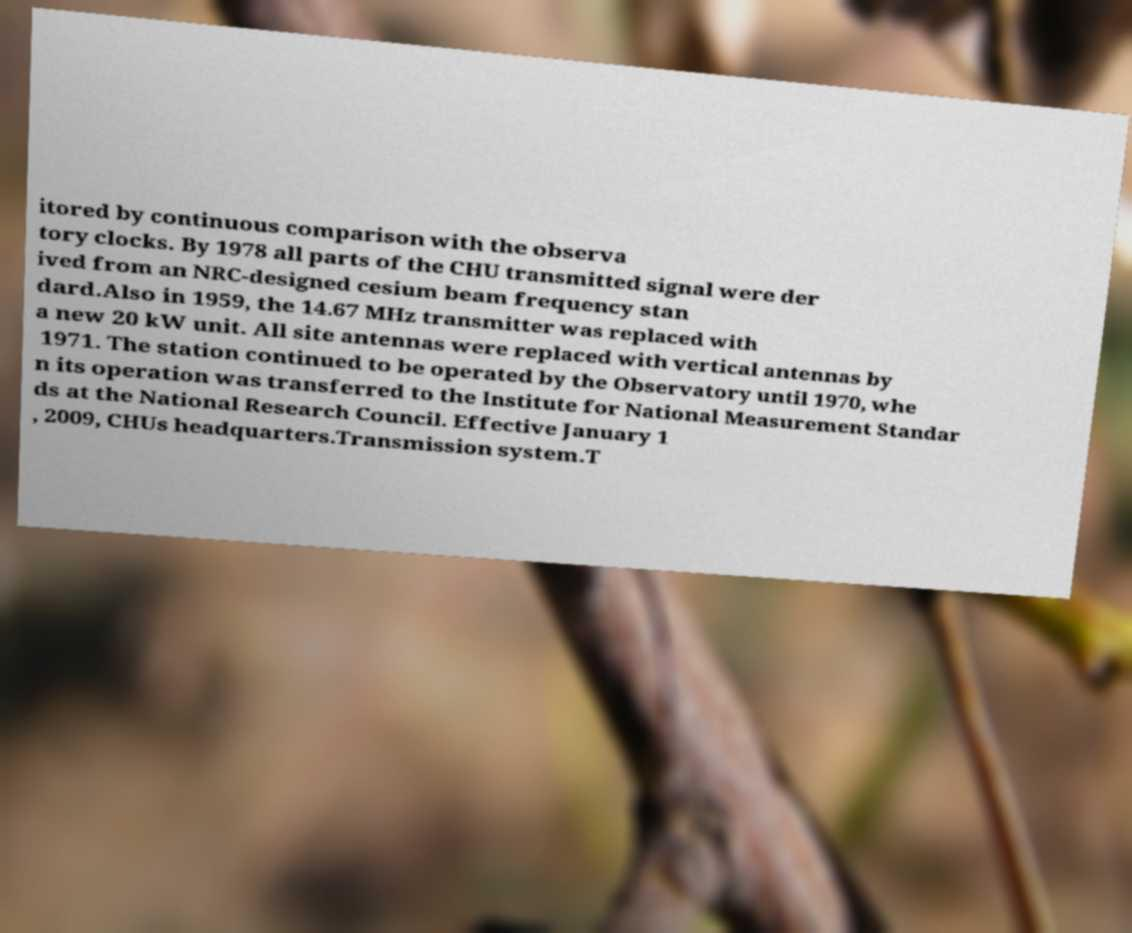Could you assist in decoding the text presented in this image and type it out clearly? itored by continuous comparison with the observa tory clocks. By 1978 all parts of the CHU transmitted signal were der ived from an NRC-designed cesium beam frequency stan dard.Also in 1959, the 14.67 MHz transmitter was replaced with a new 20 kW unit. All site antennas were replaced with vertical antennas by 1971. The station continued to be operated by the Observatory until 1970, whe n its operation was transferred to the Institute for National Measurement Standar ds at the National Research Council. Effective January 1 , 2009, CHUs headquarters.Transmission system.T 